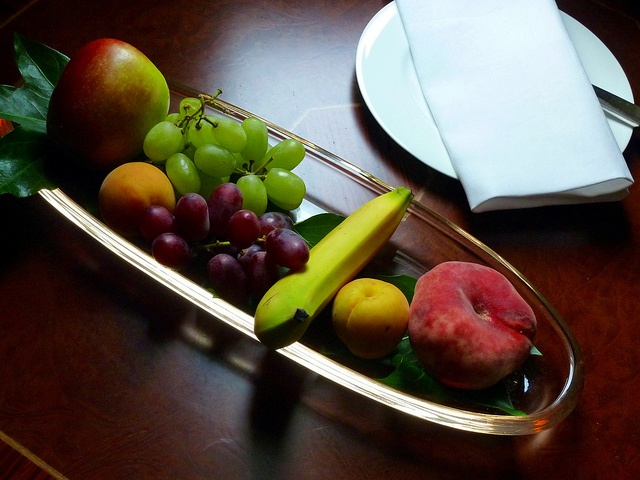Describe the objects in this image and their specific colors. I can see dining table in black, white, maroon, and gray tones, apple in black, maroon, and olive tones, banana in black, olive, and khaki tones, orange in black, gold, and olive tones, and orange in black, olive, maroon, and orange tones in this image. 